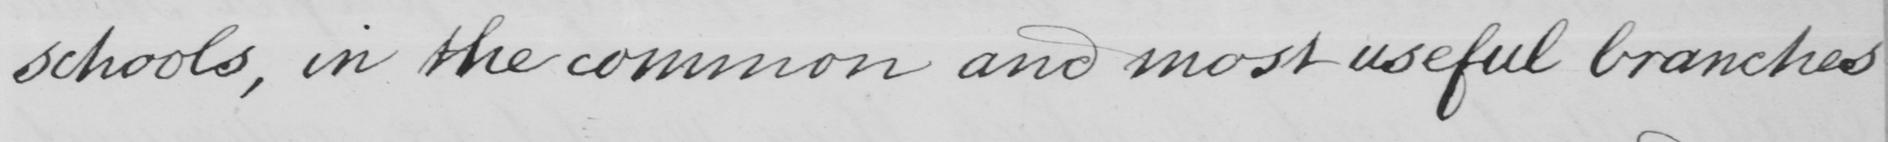What text is written in this handwritten line? schools , in the common and most useful branches 